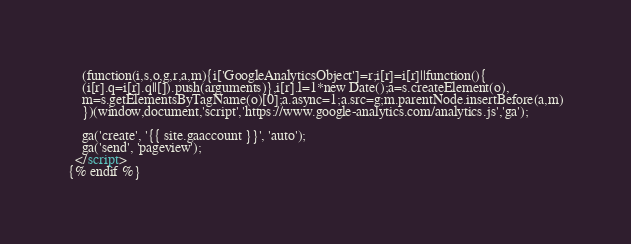<code> <loc_0><loc_0><loc_500><loc_500><_HTML_>    (function(i,s,o,g,r,a,m){i['GoogleAnalyticsObject']=r;i[r]=i[r]||function(){
    (i[r].q=i[r].q||[]).push(arguments)},i[r].l=1*new Date();a=s.createElement(o),
    m=s.getElementsByTagName(o)[0];a.async=1;a.src=g;m.parentNode.insertBefore(a,m)
    })(window,document,'script','https://www.google-analytics.com/analytics.js','ga');

    ga('create', '{{ site.gaaccount }}', 'auto');
    ga('send', 'pageview');
  </script>
{% endif %}
</code> 